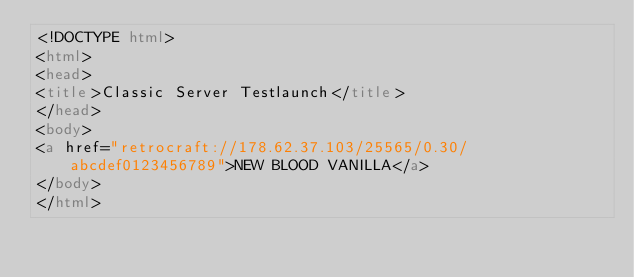Convert code to text. <code><loc_0><loc_0><loc_500><loc_500><_HTML_><!DOCTYPE html>
<html>
<head>
<title>Classic Server Testlaunch</title>
</head>
<body>
<a href="retrocraft://178.62.37.103/25565/0.30/abcdef0123456789">NEW BLOOD VANILLA</a>
</body>
</html></code> 